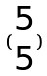Convert formula to latex. <formula><loc_0><loc_0><loc_500><loc_500>( \begin{matrix} 5 \\ 5 \end{matrix} )</formula> 